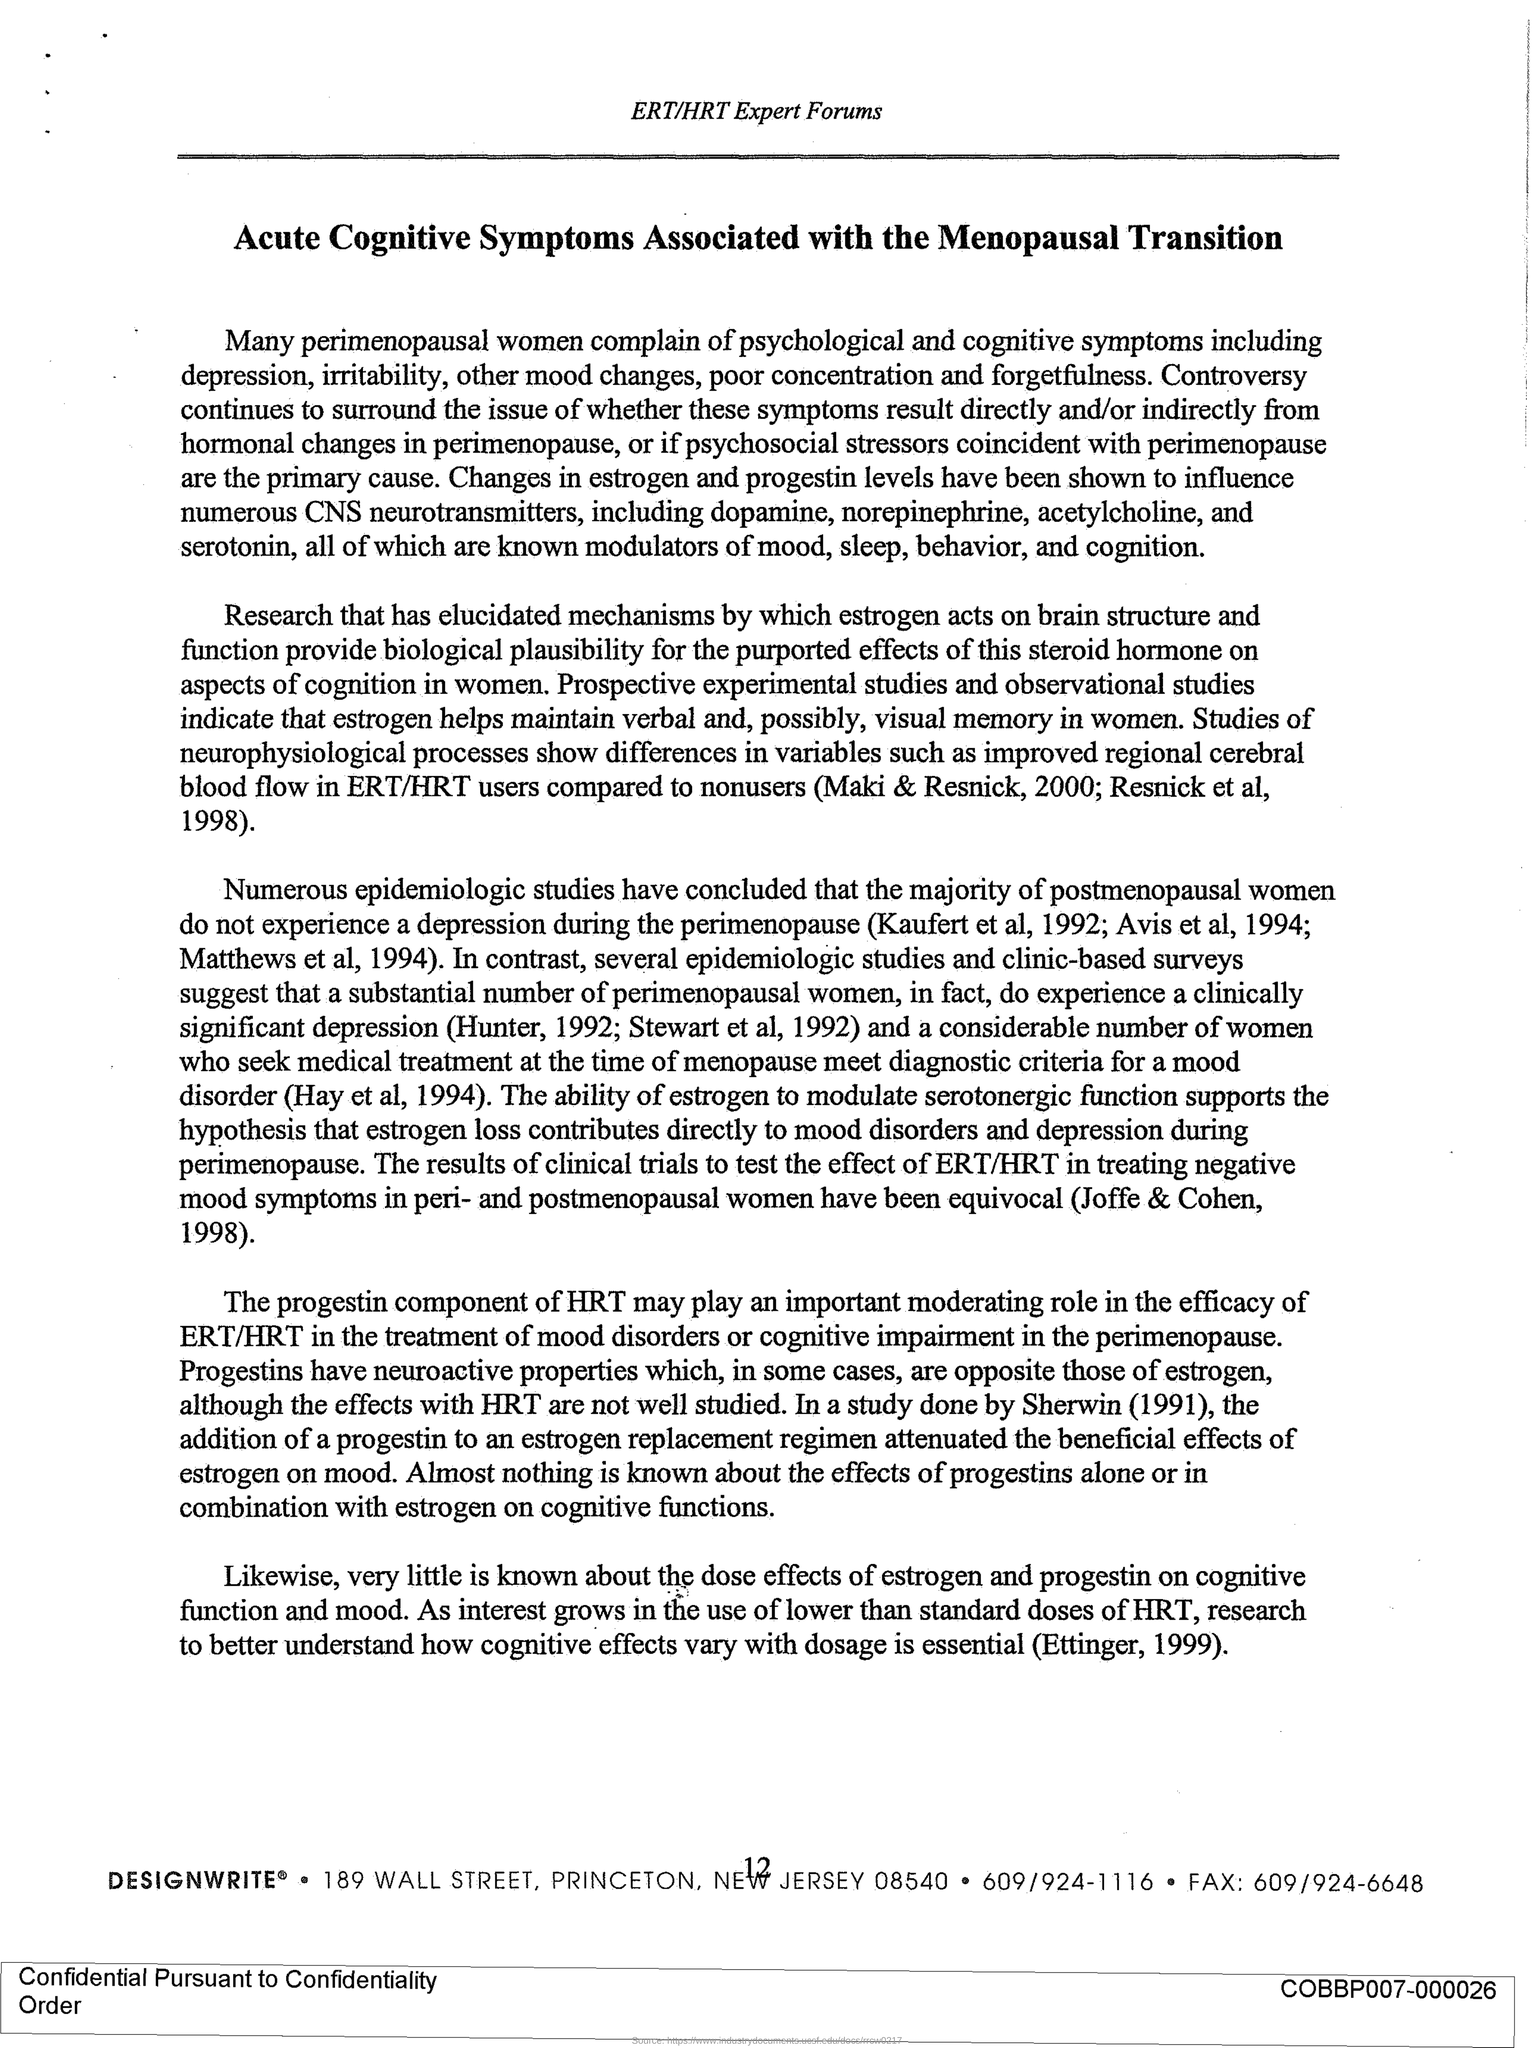What is heading of the document?
Give a very brief answer. Acute Cognitive Symptoms Associated with the Menopausal Transition. Who complains of psychological and cognitive symptoms?
Provide a short and direct response. Perimenopausal women. Who do not experience depression?
Offer a very short reply. Post menopausal women. Which component of HRT play an important role inERT/HRT treatment?
Your answer should be compact. Progestin. Who generally complain about psychological and cognitive symptoms?
Give a very brief answer. Perimenopausal women. 